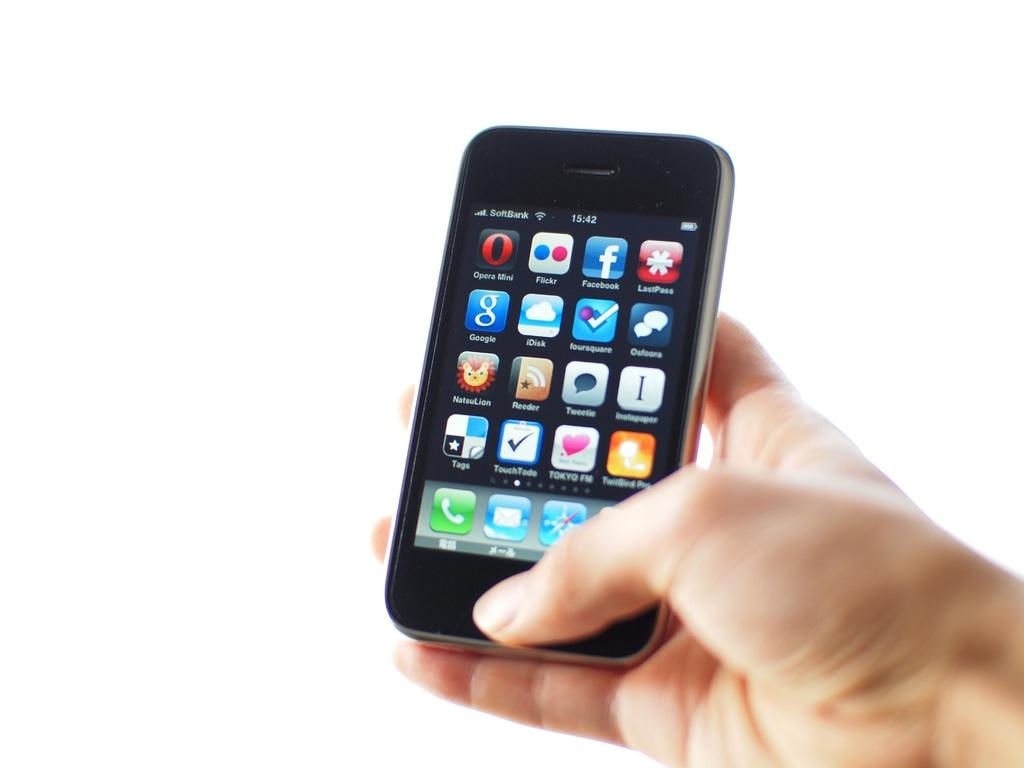<image>
Describe the image concisely. A female hand is holding a black cell phone with many apps on the screen, including google and Flickr. 